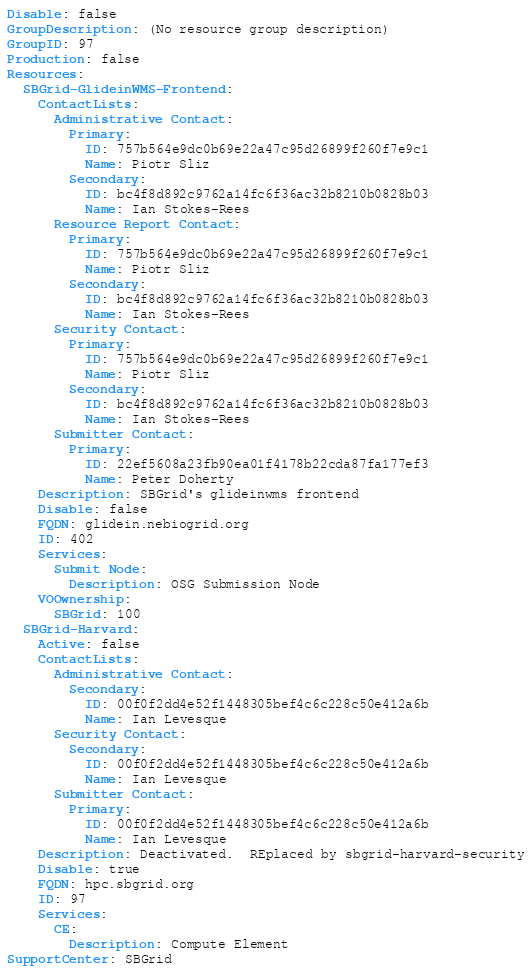<code> <loc_0><loc_0><loc_500><loc_500><_YAML_>Disable: false
GroupDescription: (No resource group description)
GroupID: 97
Production: false
Resources:
  SBGrid-GlideinWMS-Frontend:
    ContactLists:
      Administrative Contact:
        Primary:
          ID: 757b564e9dc0b69e22a47c95d26899f260f7e9c1
          Name: Piotr Sliz
        Secondary:
          ID: bc4f8d892c9762a14fc6f36ac32b8210b0828b03
          Name: Ian Stokes-Rees
      Resource Report Contact:
        Primary:
          ID: 757b564e9dc0b69e22a47c95d26899f260f7e9c1
          Name: Piotr Sliz
        Secondary:
          ID: bc4f8d892c9762a14fc6f36ac32b8210b0828b03
          Name: Ian Stokes-Rees
      Security Contact:
        Primary:
          ID: 757b564e9dc0b69e22a47c95d26899f260f7e9c1
          Name: Piotr Sliz
        Secondary:
          ID: bc4f8d892c9762a14fc6f36ac32b8210b0828b03
          Name: Ian Stokes-Rees
      Submitter Contact:
        Primary:
          ID: 22ef5608a23fb90ea01f4178b22cda87fa177ef3
          Name: Peter Doherty
    Description: SBGrid's glideinwms frontend
    Disable: false
    FQDN: glidein.nebiogrid.org
    ID: 402
    Services:
      Submit Node:
        Description: OSG Submission Node
    VOOwnership:
      SBGrid: 100
  SBGrid-Harvard:
    Active: false
    ContactLists:
      Administrative Contact:
        Secondary:
          ID: 00f0f2dd4e52f1448305bef4c6c228c50e412a6b
          Name: Ian Levesque
      Security Contact:
        Secondary:
          ID: 00f0f2dd4e52f1448305bef4c6c228c50e412a6b
          Name: Ian Levesque
      Submitter Contact:
        Primary:
          ID: 00f0f2dd4e52f1448305bef4c6c228c50e412a6b
          Name: Ian Levesque
    Description: Deactivated.  REplaced by sbgrid-harvard-security
    Disable: true
    FQDN: hpc.sbgrid.org
    ID: 97
    Services:
      CE:
        Description: Compute Element
SupportCenter: SBGrid
</code> 